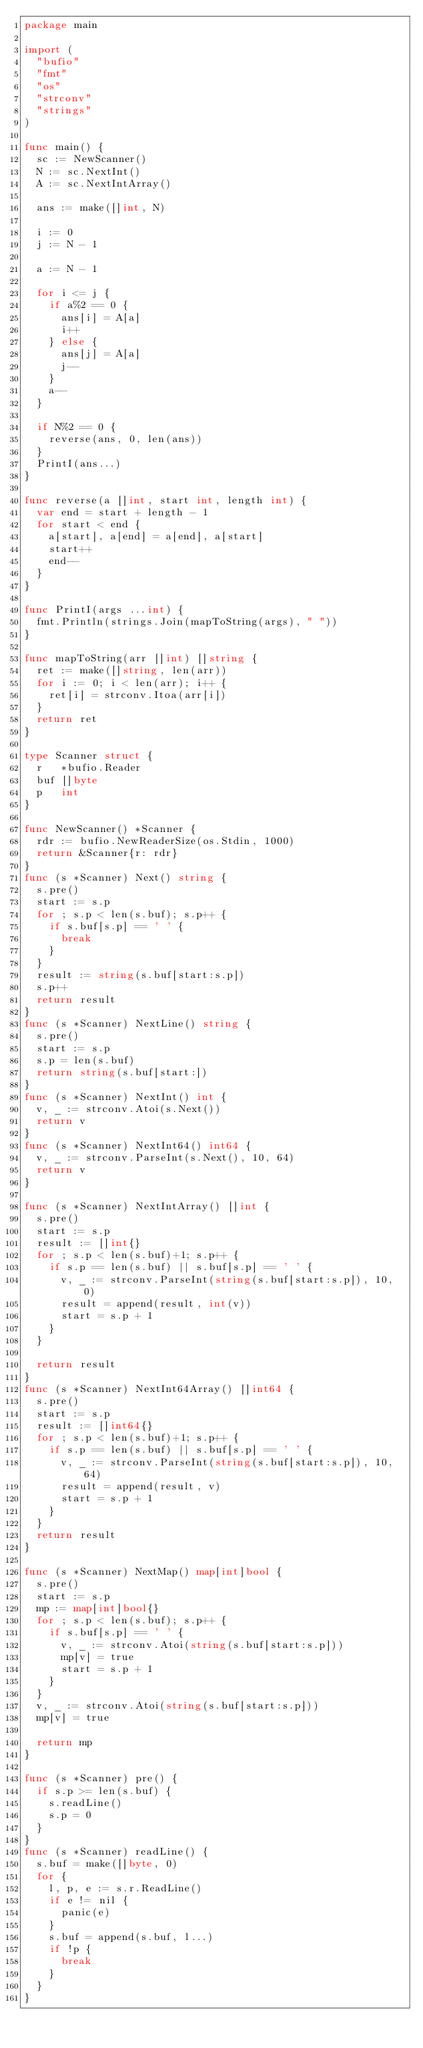<code> <loc_0><loc_0><loc_500><loc_500><_Go_>package main

import (
	"bufio"
	"fmt"
	"os"
	"strconv"
	"strings"
)

func main() {
	sc := NewScanner()
	N := sc.NextInt()
	A := sc.NextIntArray()

	ans := make([]int, N)

	i := 0
	j := N - 1

	a := N - 1

	for i <= j {
		if a%2 == 0 {
			ans[i] = A[a]
			i++
		} else {
			ans[j] = A[a]
			j--
		}
		a--
	}

	if N%2 == 0 {
		reverse(ans, 0, len(ans))
	}
	PrintI(ans...)
}

func reverse(a []int, start int, length int) {
	var end = start + length - 1
	for start < end {
		a[start], a[end] = a[end], a[start]
		start++
		end--
	}
}

func PrintI(args ...int) {
	fmt.Println(strings.Join(mapToString(args), " "))
}

func mapToString(arr []int) []string {
	ret := make([]string, len(arr))
	for i := 0; i < len(arr); i++ {
		ret[i] = strconv.Itoa(arr[i])
	}
	return ret
}

type Scanner struct {
	r   *bufio.Reader
	buf []byte
	p   int
}

func NewScanner() *Scanner {
	rdr := bufio.NewReaderSize(os.Stdin, 1000)
	return &Scanner{r: rdr}
}
func (s *Scanner) Next() string {
	s.pre()
	start := s.p
	for ; s.p < len(s.buf); s.p++ {
		if s.buf[s.p] == ' ' {
			break
		}
	}
	result := string(s.buf[start:s.p])
	s.p++
	return result
}
func (s *Scanner) NextLine() string {
	s.pre()
	start := s.p
	s.p = len(s.buf)
	return string(s.buf[start:])
}
func (s *Scanner) NextInt() int {
	v, _ := strconv.Atoi(s.Next())
	return v
}
func (s *Scanner) NextInt64() int64 {
	v, _ := strconv.ParseInt(s.Next(), 10, 64)
	return v
}

func (s *Scanner) NextIntArray() []int {
	s.pre()
	start := s.p
	result := []int{}
	for ; s.p < len(s.buf)+1; s.p++ {
		if s.p == len(s.buf) || s.buf[s.p] == ' ' {
			v, _ := strconv.ParseInt(string(s.buf[start:s.p]), 10, 0)
			result = append(result, int(v))
			start = s.p + 1
		}
	}

	return result
}
func (s *Scanner) NextInt64Array() []int64 {
	s.pre()
	start := s.p
	result := []int64{}
	for ; s.p < len(s.buf)+1; s.p++ {
		if s.p == len(s.buf) || s.buf[s.p] == ' ' {
			v, _ := strconv.ParseInt(string(s.buf[start:s.p]), 10, 64)
			result = append(result, v)
			start = s.p + 1
		}
	}
	return result
}

func (s *Scanner) NextMap() map[int]bool {
	s.pre()
	start := s.p
	mp := map[int]bool{}
	for ; s.p < len(s.buf); s.p++ {
		if s.buf[s.p] == ' ' {
			v, _ := strconv.Atoi(string(s.buf[start:s.p]))
			mp[v] = true
			start = s.p + 1
		}
	}
	v, _ := strconv.Atoi(string(s.buf[start:s.p]))
	mp[v] = true

	return mp
}

func (s *Scanner) pre() {
	if s.p >= len(s.buf) {
		s.readLine()
		s.p = 0
	}
}
func (s *Scanner) readLine() {
	s.buf = make([]byte, 0)
	for {
		l, p, e := s.r.ReadLine()
		if e != nil {
			panic(e)
		}
		s.buf = append(s.buf, l...)
		if !p {
			break
		}
	}
}
</code> 